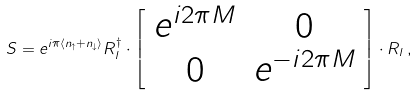<formula> <loc_0><loc_0><loc_500><loc_500>S = e ^ { i \pi \langle n _ { \uparrow } + n _ { \downarrow } \rangle } R ^ { \dagger } _ { l } \cdot \left [ \begin{array} { c c } e ^ { i 2 \pi M } & 0 \\ 0 & e ^ { - i 2 \pi M } \end{array} \right ] \cdot R _ { l } \, ,</formula> 